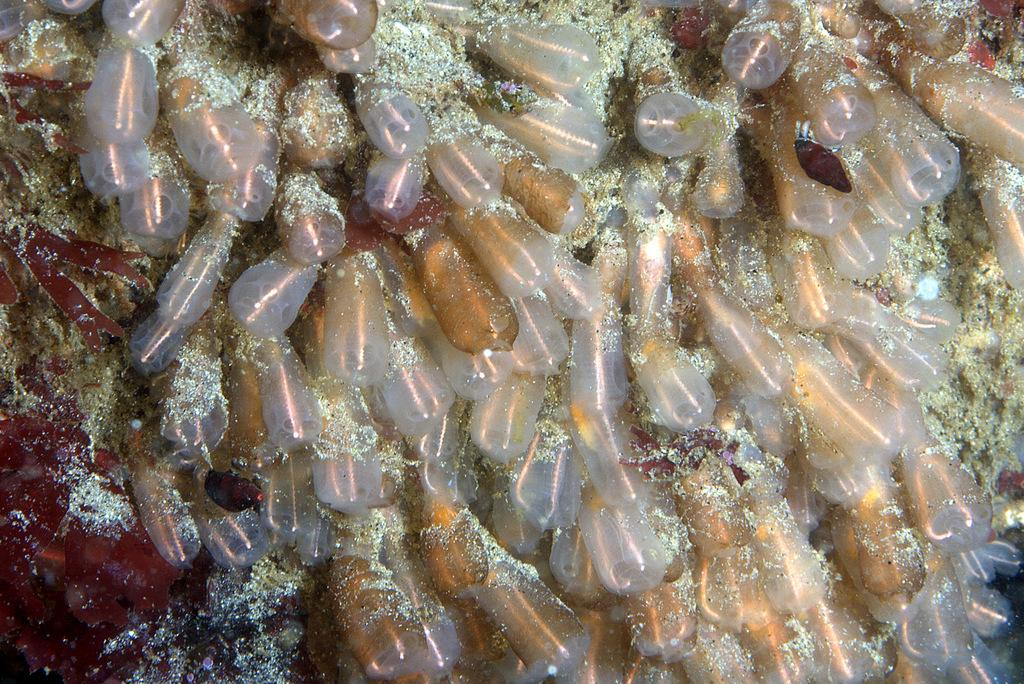What is the name of the manager of the plane that was born in the image? There is no plane, manager, or birth depicted in the image, so this information cannot be determined. 